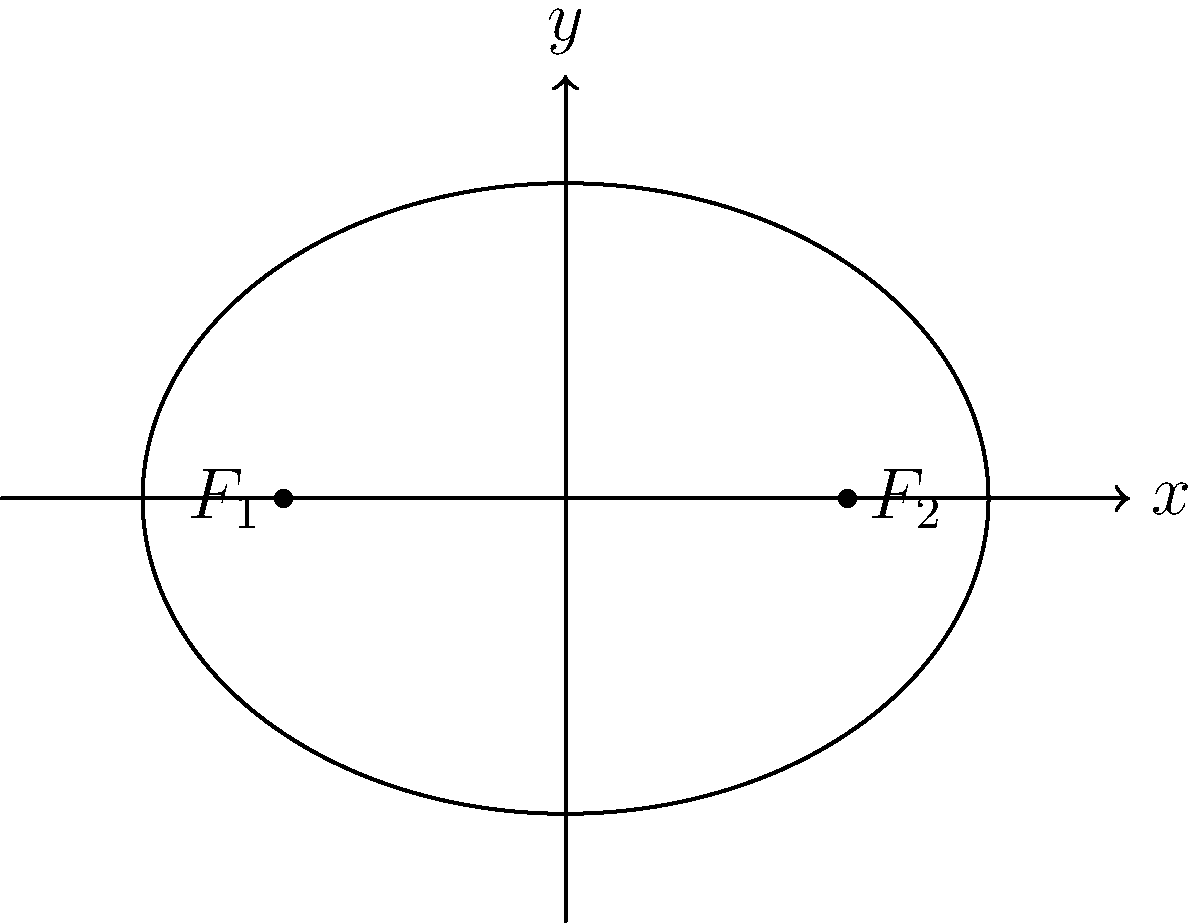In the context of intersectionality and power dynamics, consider the ellipse shown above. If the distance between the foci is 4 units and the length of the major axis is 6 units, calculate the eccentricity of this ellipse. How might this mathematical concept of eccentricity be used as a metaphor to discuss the varying degrees of marginalization experienced by different intersectional identities in social systems? To calculate the eccentricity of the ellipse, we'll follow these steps:

1. Identify the given information:
   - Distance between foci (2c) = 4 units
   - Length of major axis (2a) = 6 units

2. Calculate c (half the distance between foci):
   $c = 4 / 2 = 2$

3. Calculate a (half the length of the major axis):
   $a = 6 / 2 = 3$

4. Use the eccentricity formula:
   $e = \frac{c}{a}$

5. Substitute the values:
   $e = \frac{2}{3}$

6. Simplify:
   $e = \frac{2}{3} \approx 0.667$

The eccentricity of this ellipse is $\frac{2}{3}$ or approximately 0.667.

Metaphorical interpretation:
In critical race theory and gender studies, the eccentricity of an ellipse can be used as a metaphor to discuss varying degrees of marginalization:

1. The center of the ellipse represents the societal norm or power center.
2. The foci represent different intersectional identities.
3. The eccentricity (ranging from 0 to 1) represents the degree of deviation from the norm or the intensity of marginalization.

An eccentricity of $\frac{2}{3}$ suggests a moderate level of marginalization. This could represent:
- Identities that face significant challenges but still have some access to power structures.
- The complex nature of intersectionality, where multiple identities interact to create unique experiences of oppression and privilege.
- The need for nuanced approaches in addressing social inequalities, recognizing that marginalization isn't binary but exists on a spectrum.

This metaphor can be used to facilitate discussions on how different intersectional identities experience varying degrees of marginalization, and how these experiences can change based on context and time, much like how the shape of an ellipse changes with its eccentricity.
Answer: $\frac{2}{3}$ 